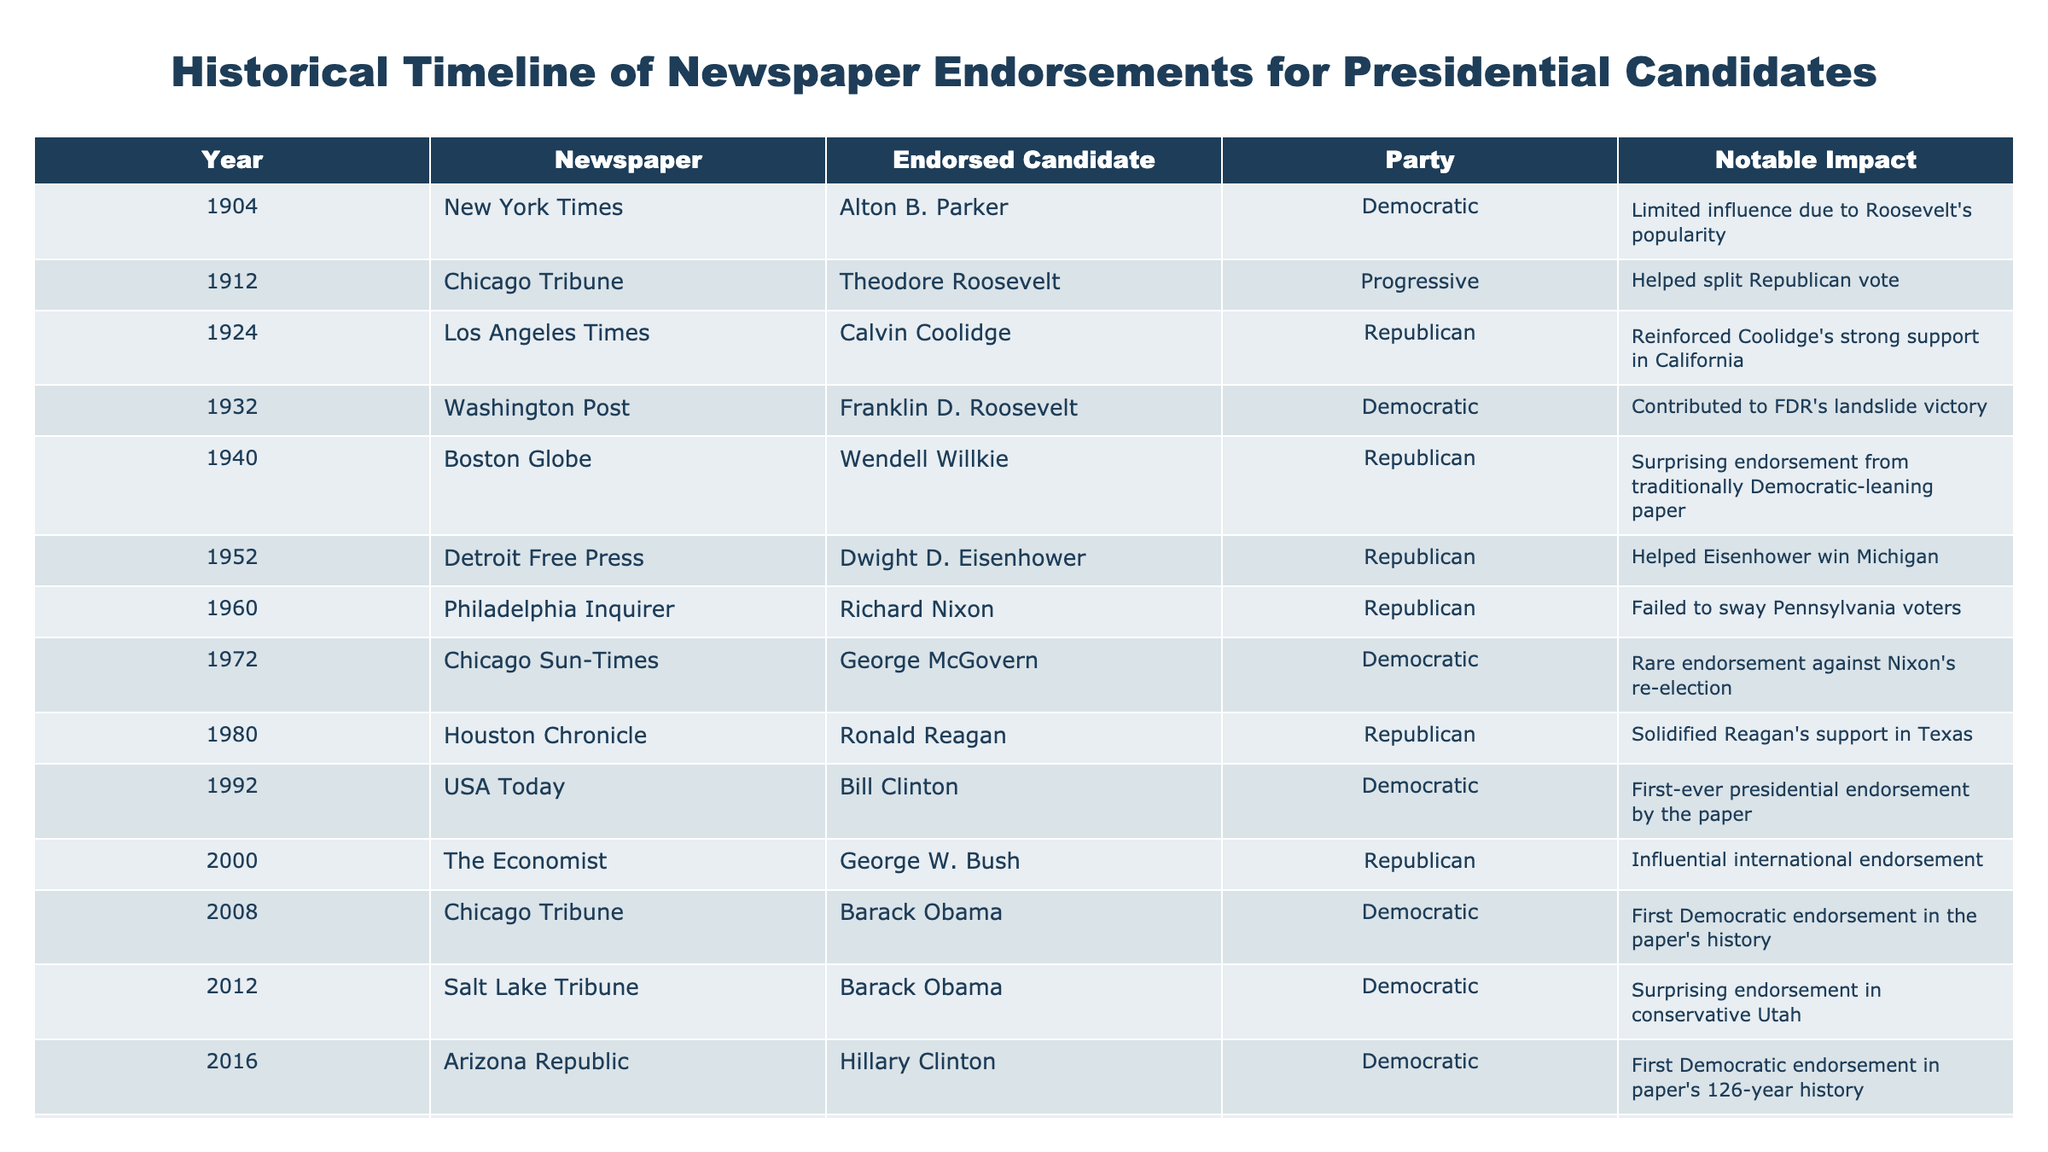What newspaper endorsed Franklin D. Roosevelt in 1932? The table directly lists the endorsements for each year. In the year 1932, the Washington Post is noted for endorsing Franklin D. Roosevelt.
Answer: Washington Post Was there a newspaper that endorsed a Republican candidate in 1960? By examining the table, the Philadelphia Inquirer is marked as endorsing Richard Nixon, who was a Republican candidate in 1960.
Answer: Yes Which candidate received the first-ever endorsement from USA Today? Looking at the data from the table, it clearly states that Bill Clinton was the candidate endorsed by USA Today in 1992.
Answer: Bill Clinton How many Democratic endorsements were made by newspapers in the 2000s? We analyze each year within the 2000s from the table, and note that Barack Obama and Joe Biden received endorsements in 2008 and 2020 respectively, as well as Bill Clinton in 1992. This totals three Democratic endorsements in the 2000s.
Answer: 2 Did any newspaper endorse a Democratic candidate in a traditionally Republican state? The Salt Lake Tribune endorsed Barack Obama in 2012, which is significant as Utah is typically a conservative state.
Answer: Yes Which endorsement was noted as surprising and why? The Boston Globe's endorsement of Wendell Willkie in 1940 stands out as it was surprising because the Globe was traditionally a Democratic-leaning publication.
Answer: Boston Globe's endorsement of Wendell Willkie In which year did Chicago Tribune endorse a candidate for the first time in history? The table indicates that Chicago Tribune endorsed Barack Obama in 2008 as its first Democratic endorsement in its history, signifying it as a landmark year.
Answer: 2008 Count the Republican endorsements recorded in the table. Scanning through the table, we find the endorsements for Theodore Roosevelt in 1912, Calvin Coolidge in 1924, Dwight D. Eisenhower in 1952, Richard Nixon in 1960, and Ronald Reagan in 1980, totaling five endorsements for Republican candidates.
Answer: 5 